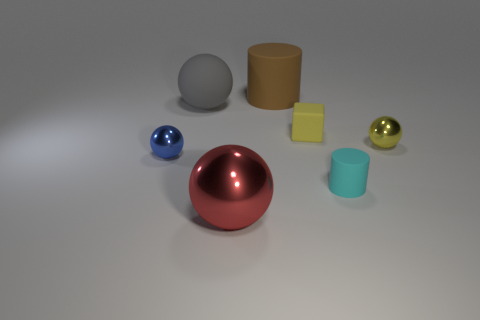There is a brown object that is the same size as the red object; what is its material?
Provide a short and direct response. Rubber. Are there fewer yellow metallic balls in front of the red metal sphere than tiny spheres that are behind the large gray matte object?
Provide a succinct answer. No. The object that is both behind the small yellow sphere and on the right side of the big rubber cylinder has what shape?
Offer a terse response. Cube. What number of gray matte objects are the same shape as the large red object?
Keep it short and to the point. 1. There is a red ball that is the same material as the yellow ball; what size is it?
Keep it short and to the point. Large. Are there more big red objects than tiny shiny cubes?
Your answer should be compact. Yes. The tiny metal sphere that is behind the tiny blue metal thing is what color?
Your answer should be compact. Yellow. There is a thing that is both behind the small yellow cube and on the right side of the red sphere; what size is it?
Give a very brief answer. Large. How many spheres have the same size as the cyan rubber object?
Give a very brief answer. 2. There is another big gray thing that is the same shape as the large metal thing; what material is it?
Provide a succinct answer. Rubber. 